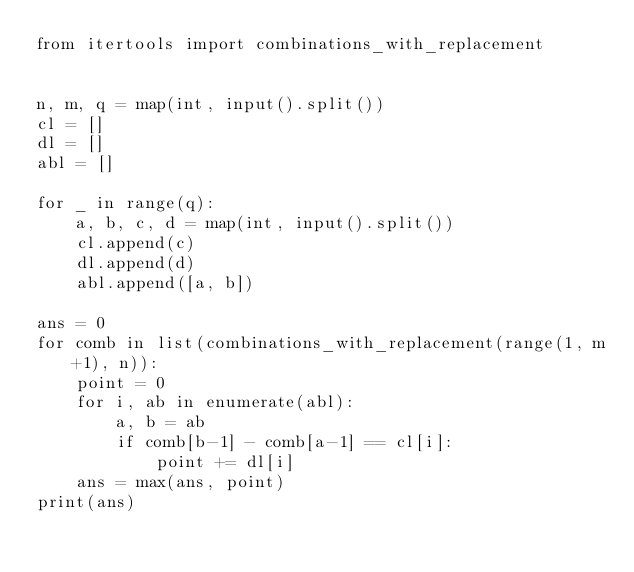<code> <loc_0><loc_0><loc_500><loc_500><_Python_>from itertools import combinations_with_replacement


n, m, q = map(int, input().split())
cl = []
dl = []
abl = []

for _ in range(q):
    a, b, c, d = map(int, input().split())
    cl.append(c)
    dl.append(d)
    abl.append([a, b])

ans = 0
for comb in list(combinations_with_replacement(range(1, m+1), n)):
    point = 0
    for i, ab in enumerate(abl):
        a, b = ab
        if comb[b-1] - comb[a-1] == cl[i]:
            point += dl[i]
    ans = max(ans, point)
print(ans)





</code> 